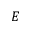Convert formula to latex. <formula><loc_0><loc_0><loc_500><loc_500>E</formula> 